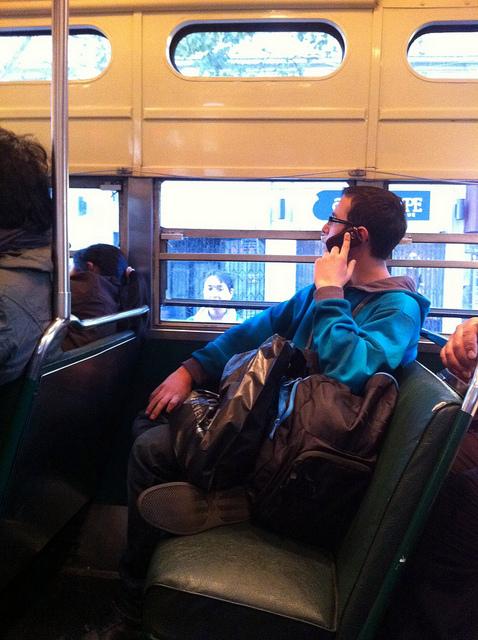Is the man riding a bike?
Give a very brief answer. No. Is this person leaving the bus?
Quick response, please. No. Is this a bus?
Short answer required. Yes. Where is the man's leg?
Keep it brief. On seat. How many people are shown on the ride?
Quick response, please. 4. What is the person holding?
Answer briefly. Phone. What is in the person's backpack?
Be succinct. Books. What is held up to the man's ear?
Concise answer only. Phone. 